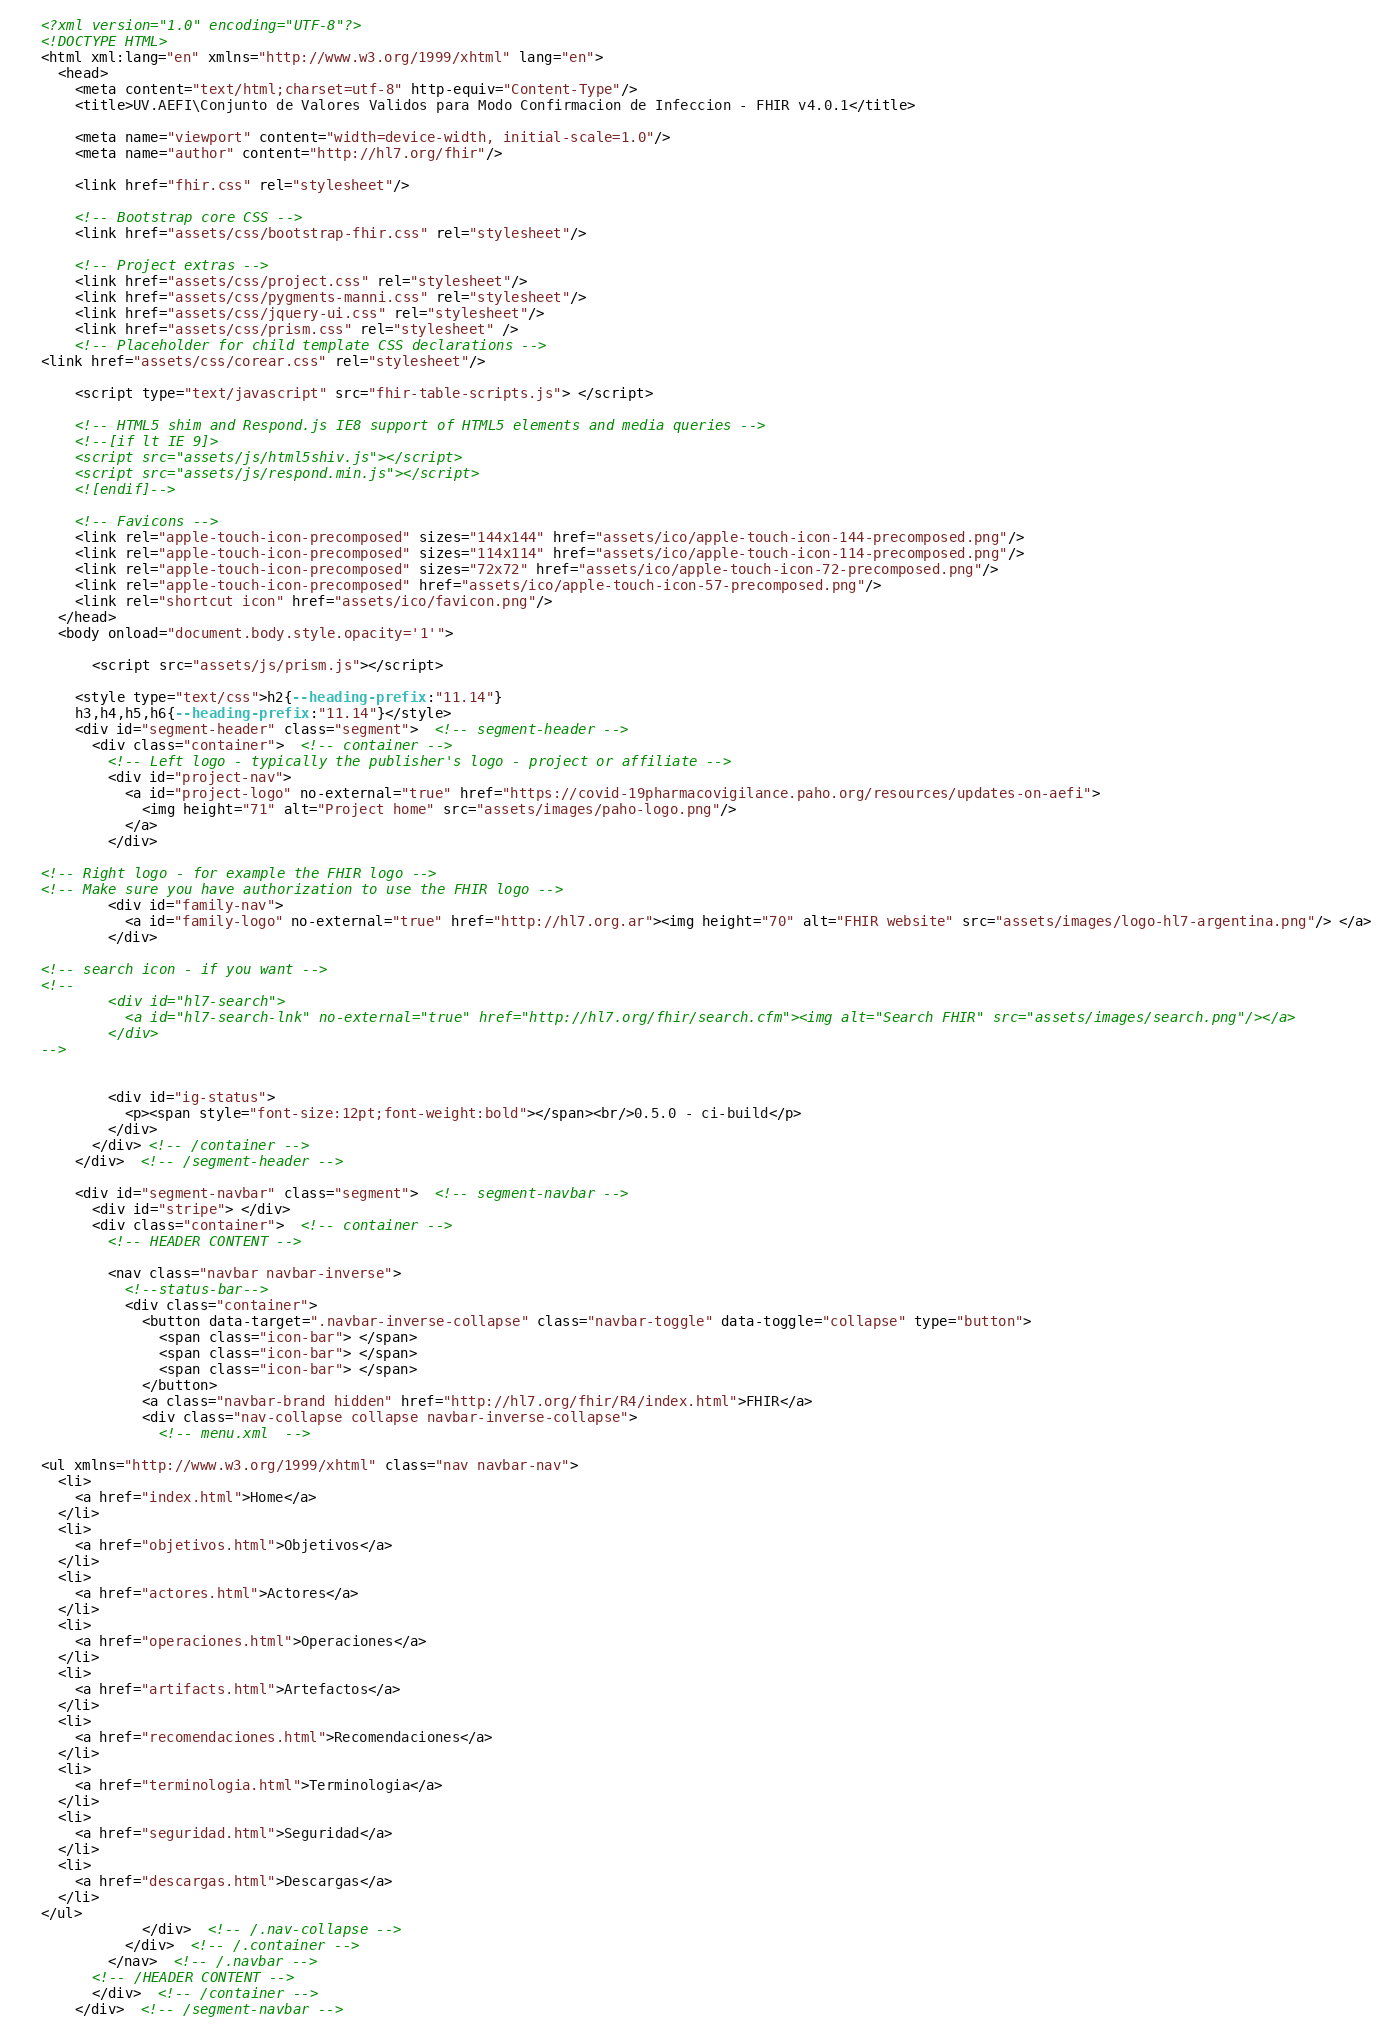<code> <loc_0><loc_0><loc_500><loc_500><_HTML_><?xml version="1.0" encoding="UTF-8"?>
<!DOCTYPE HTML>
<html xml:lang="en" xmlns="http://www.w3.org/1999/xhtml" lang="en">
  <head>
    <meta content="text/html;charset=utf-8" http-equiv="Content-Type"/>
    <title>UV.AEFI\Conjunto de Valores Validos para Modo Confirmacion de Infeccion - FHIR v4.0.1</title>

    <meta name="viewport" content="width=device-width, initial-scale=1.0"/>
    <meta name="author" content="http://hl7.org/fhir"/>

    <link href="fhir.css" rel="stylesheet"/>

    <!-- Bootstrap core CSS -->
    <link href="assets/css/bootstrap-fhir.css" rel="stylesheet"/>

    <!-- Project extras -->
    <link href="assets/css/project.css" rel="stylesheet"/>
    <link href="assets/css/pygments-manni.css" rel="stylesheet"/>
    <link href="assets/css/jquery-ui.css" rel="stylesheet"/>
  	<link href="assets/css/prism.css" rel="stylesheet" />
    <!-- Placeholder for child template CSS declarations -->
<link href="assets/css/corear.css" rel="stylesheet"/>

    <script type="text/javascript" src="fhir-table-scripts.js"> </script>

    <!-- HTML5 shim and Respond.js IE8 support of HTML5 elements and media queries -->
    <!--[if lt IE 9]>
    <script src="assets/js/html5shiv.js"></script>
    <script src="assets/js/respond.min.js"></script>
    <![endif]-->

    <!-- Favicons -->
    <link rel="apple-touch-icon-precomposed" sizes="144x144" href="assets/ico/apple-touch-icon-144-precomposed.png"/>
    <link rel="apple-touch-icon-precomposed" sizes="114x114" href="assets/ico/apple-touch-icon-114-precomposed.png"/>
    <link rel="apple-touch-icon-precomposed" sizes="72x72" href="assets/ico/apple-touch-icon-72-precomposed.png"/>
    <link rel="apple-touch-icon-precomposed" href="assets/ico/apple-touch-icon-57-precomposed.png"/>
    <link rel="shortcut icon" href="assets/ico/favicon.png"/>
  </head>
  <body onload="document.body.style.opacity='1'">

	  <script src="assets/js/prism.js"></script>

    <style type="text/css">h2{--heading-prefix:"11.14"}
    h3,h4,h5,h6{--heading-prefix:"11.14"}</style>
    <div id="segment-header" class="segment">  <!-- segment-header -->
      <div class="container">  <!-- container -->
        <!-- Left logo - typically the publisher's logo - project or affiliate -->
        <div id="project-nav">
          <a id="project-logo" no-external="true" href="https://covid-19pharmacovigilance.paho.org/resources/updates-on-aefi">
            <img height="71" alt="Project home" src="assets/images/paho-logo.png"/>
          </a>
        </div>

<!-- Right logo - for example the FHIR logo -->
<!-- Make sure you have authorization to use the FHIR logo -->
        <div id="family-nav">
          <a id="family-logo" no-external="true" href="http://hl7.org.ar"><img height="70" alt="FHIR website" src="assets/images/logo-hl7-argentina.png"/> </a>
        </div>

<!-- search icon - if you want -->
<!--
        <div id="hl7-search">
          <a id="hl7-search-lnk" no-external="true" href="http://hl7.org/fhir/search.cfm"><img alt="Search FHIR" src="assets/images/search.png"/></a>
        </div>
-->


        <div id="ig-status">
          <p><span style="font-size:12pt;font-weight:bold"></span><br/>0.5.0 - ci-build</p>
        </div>
      </div> <!-- /container -->
    </div>  <!-- /segment-header -->

    <div id="segment-navbar" class="segment">  <!-- segment-navbar -->
      <div id="stripe"> </div>
      <div class="container">  <!-- container -->
        <!-- HEADER CONTENT -->

        <nav class="navbar navbar-inverse">
          <!--status-bar-->
          <div class="container">
            <button data-target=".navbar-inverse-collapse" class="navbar-toggle" data-toggle="collapse" type="button">
              <span class="icon-bar"> </span>
              <span class="icon-bar"> </span>
              <span class="icon-bar"> </span>
            </button>
            <a class="navbar-brand hidden" href="http://hl7.org/fhir/R4/index.html">FHIR</a>
            <div class="nav-collapse collapse navbar-inverse-collapse">
              <!-- menu.xml  -->

<ul xmlns="http://www.w3.org/1999/xhtml" class="nav navbar-nav">
  <li>
    <a href="index.html">Home</a>
  </li>
  <li>
    <a href="objetivos.html">Objetivos</a>
  </li>
  <li>
    <a href="actores.html">Actores</a>
  </li>
  <li>
    <a href="operaciones.html">Operaciones</a>
  </li>
  <li>
    <a href="artifacts.html">Artefactos</a>
  </li>
  <li>
    <a href="recomendaciones.html">Recomendaciones</a>
  </li>
  <li>
    <a href="terminologia.html">Terminologia</a>
  </li>
  <li>
    <a href="seguridad.html">Seguridad</a>
  </li>
  <li>
    <a href="descargas.html">Descargas</a>
  </li>
</ul>
            </div>  <!-- /.nav-collapse -->
          </div>  <!-- /.container -->
        </nav>  <!-- /.navbar -->
      <!-- /HEADER CONTENT -->
      </div>  <!-- /container -->
    </div>  <!-- /segment-navbar --></code> 